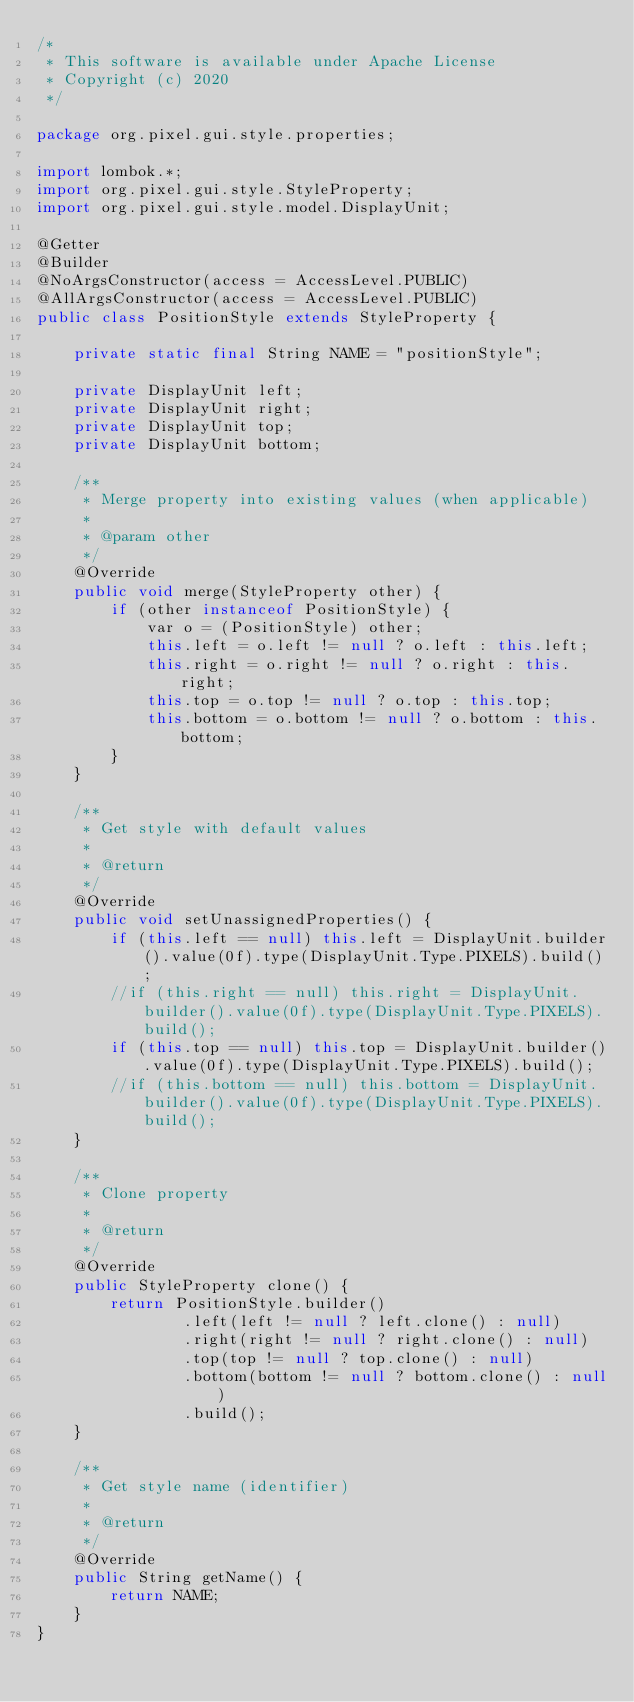Convert code to text. <code><loc_0><loc_0><loc_500><loc_500><_Java_>/*
 * This software is available under Apache License
 * Copyright (c) 2020
 */

package org.pixel.gui.style.properties;

import lombok.*;
import org.pixel.gui.style.StyleProperty;
import org.pixel.gui.style.model.DisplayUnit;

@Getter
@Builder
@NoArgsConstructor(access = AccessLevel.PUBLIC)
@AllArgsConstructor(access = AccessLevel.PUBLIC)
public class PositionStyle extends StyleProperty {

    private static final String NAME = "positionStyle";

    private DisplayUnit left;
    private DisplayUnit right;
    private DisplayUnit top;
    private DisplayUnit bottom;

    /**
     * Merge property into existing values (when applicable)
     *
     * @param other
     */
    @Override
    public void merge(StyleProperty other) {
        if (other instanceof PositionStyle) {
            var o = (PositionStyle) other;
            this.left = o.left != null ? o.left : this.left;
            this.right = o.right != null ? o.right : this.right;
            this.top = o.top != null ? o.top : this.top;
            this.bottom = o.bottom != null ? o.bottom : this.bottom;
        }
    }

    /**
     * Get style with default values
     *
     * @return
     */
    @Override
    public void setUnassignedProperties() {
        if (this.left == null) this.left = DisplayUnit.builder().value(0f).type(DisplayUnit.Type.PIXELS).build();
        //if (this.right == null) this.right = DisplayUnit.builder().value(0f).type(DisplayUnit.Type.PIXELS).build();
        if (this.top == null) this.top = DisplayUnit.builder().value(0f).type(DisplayUnit.Type.PIXELS).build();
        //if (this.bottom == null) this.bottom = DisplayUnit.builder().value(0f).type(DisplayUnit.Type.PIXELS).build();
    }

    /**
     * Clone property
     *
     * @return
     */
    @Override
    public StyleProperty clone() {
        return PositionStyle.builder()
                .left(left != null ? left.clone() : null)
                .right(right != null ? right.clone() : null)
                .top(top != null ? top.clone() : null)
                .bottom(bottom != null ? bottom.clone() : null)
                .build();
    }

    /**
     * Get style name (identifier)
     *
     * @return
     */
    @Override
    public String getName() {
        return NAME;
    }
}
</code> 